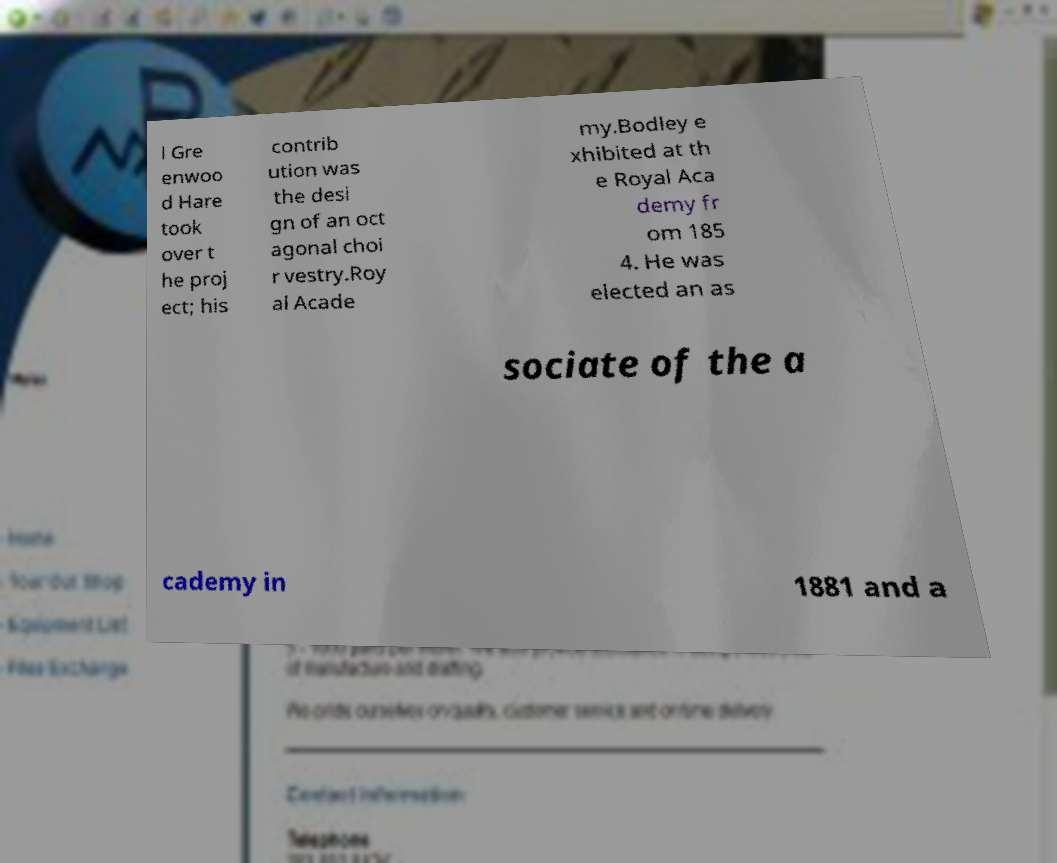Could you assist in decoding the text presented in this image and type it out clearly? l Gre enwoo d Hare took over t he proj ect; his contrib ution was the desi gn of an oct agonal choi r vestry.Roy al Acade my.Bodley e xhibited at th e Royal Aca demy fr om 185 4. He was elected an as sociate of the a cademy in 1881 and a 